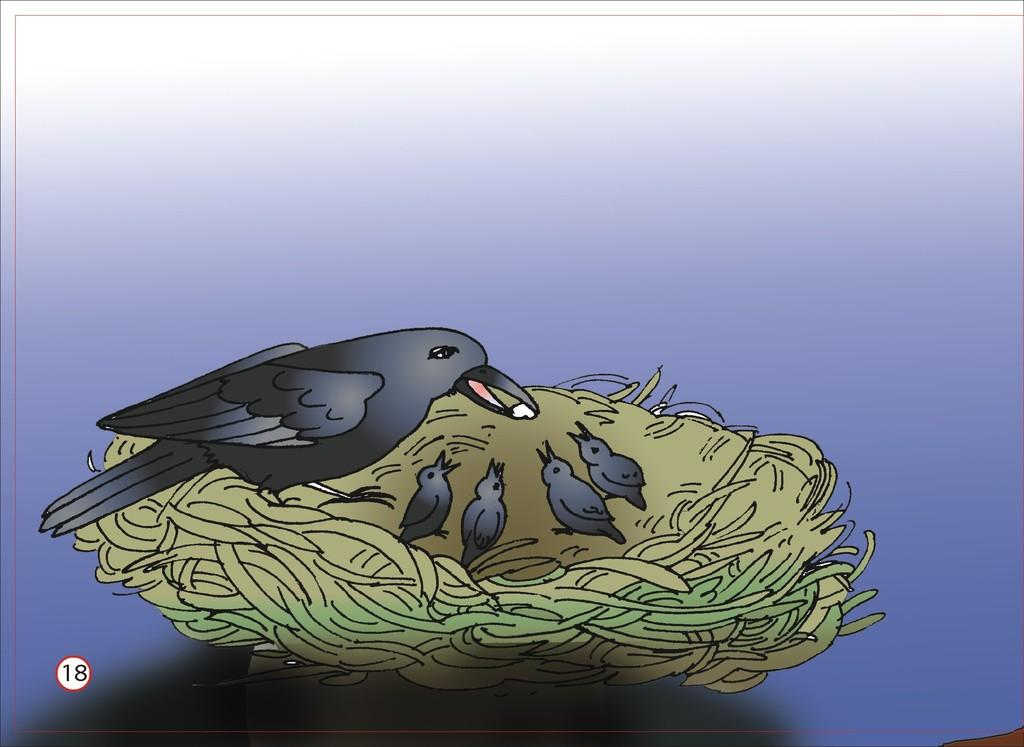What type of picture is in the image? The image contains an animated picture. What animals are depicted in the animated picture? The animated picture depicts birds. Where are the birds located in the animated picture? The birds are standing on a nest. What type of tooth can be seen in the image? There is no tooth present in the image; it features an animated picture of birds standing on a nest. What kind of shelf is visible in the image? There is no shelf present in the image; it contains an animated picture of birds standing on a nest. 